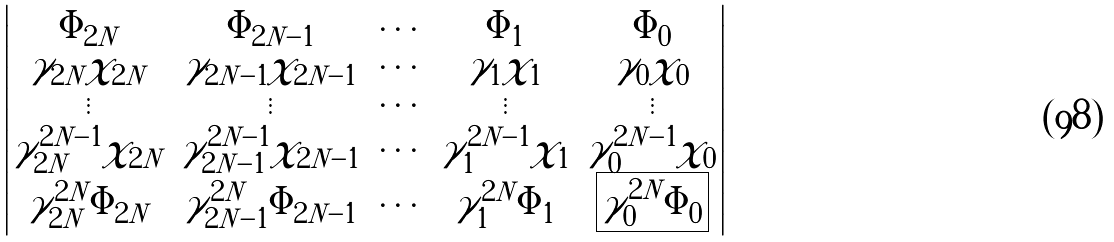<formula> <loc_0><loc_0><loc_500><loc_500>\begin{vmatrix} \Phi _ { 2 N } & \Phi _ { 2 N - 1 } & \cdots & \Phi _ { 1 } & \Phi _ { 0 } \\ \gamma _ { 2 N } \chi _ { 2 N } & \gamma _ { 2 N - 1 } \chi _ { 2 N - 1 } & \cdots & \gamma _ { 1 } \chi _ { 1 } & \gamma _ { 0 } \chi _ { 0 } \\ \vdots & \vdots & \cdots & \vdots & \vdots \\ \gamma ^ { 2 N - 1 } _ { 2 N } \chi _ { 2 N } & \gamma ^ { 2 N - 1 } _ { 2 N - 1 } \chi _ { 2 N - 1 } & \cdots & \gamma ^ { 2 N - 1 } _ { 1 } \chi _ { 1 } & \gamma ^ { 2 N - 1 } _ { 0 } \chi _ { 0 } \\ \gamma ^ { 2 N } _ { 2 N } \Phi _ { 2 N } & \gamma ^ { 2 N } _ { 2 N - 1 } \Phi _ { 2 N - 1 } & \cdots & \gamma ^ { 2 N } _ { 1 } \Phi _ { 1 } & { \boxed { \gamma ^ { 2 N } _ { 0 } \Phi _ { 0 } } } \end{vmatrix}</formula> 